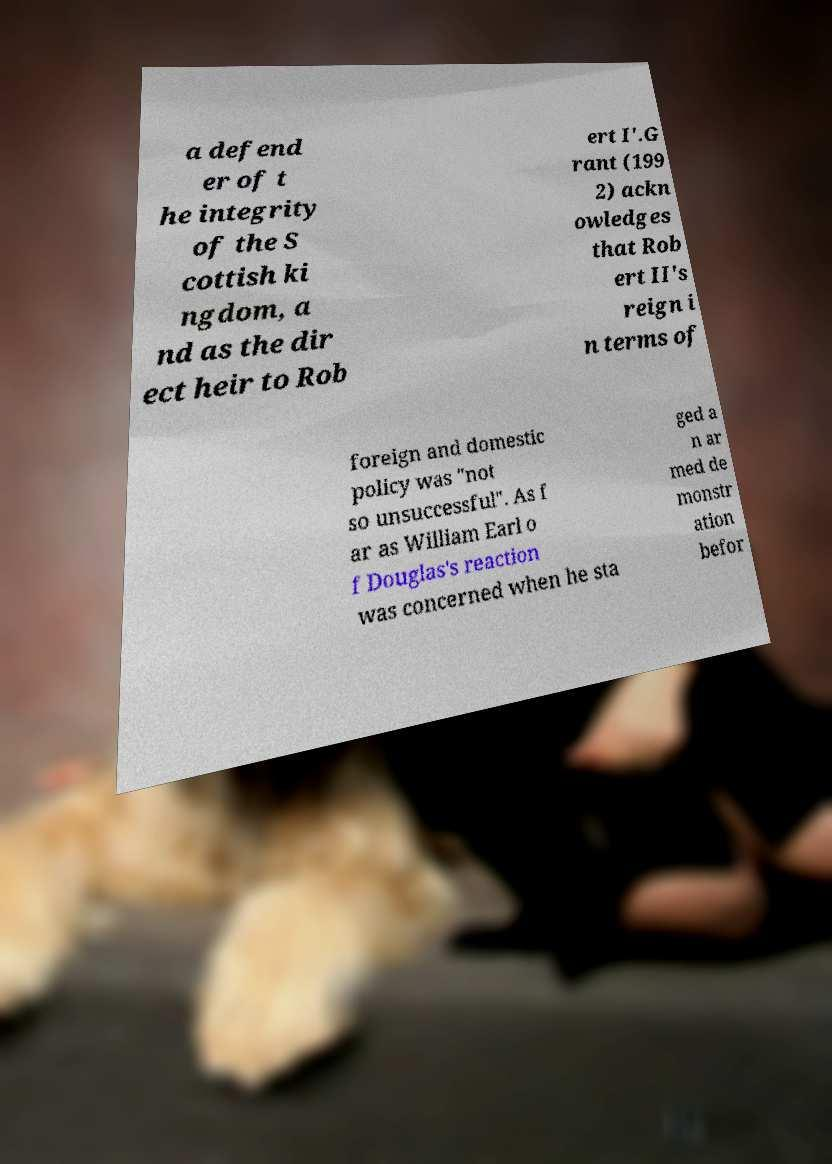Please identify and transcribe the text found in this image. a defend er of t he integrity of the S cottish ki ngdom, a nd as the dir ect heir to Rob ert I'.G rant (199 2) ackn owledges that Rob ert II's reign i n terms of foreign and domestic policy was "not so unsuccessful". As f ar as William Earl o f Douglas's reaction was concerned when he sta ged a n ar med de monstr ation befor 